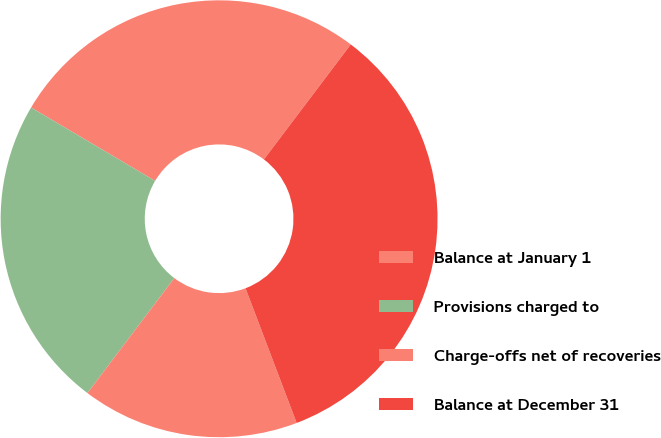Convert chart. <chart><loc_0><loc_0><loc_500><loc_500><pie_chart><fcel>Balance at January 1<fcel>Provisions charged to<fcel>Charge-offs net of recoveries<fcel>Balance at December 31<nl><fcel>26.79%<fcel>23.21%<fcel>16.07%<fcel>33.93%<nl></chart> 